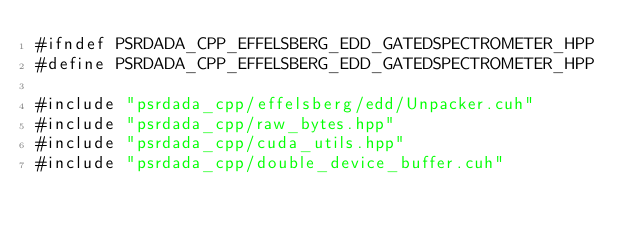Convert code to text. <code><loc_0><loc_0><loc_500><loc_500><_Cuda_>#ifndef PSRDADA_CPP_EFFELSBERG_EDD_GATEDSPECTROMETER_HPP
#define PSRDADA_CPP_EFFELSBERG_EDD_GATEDSPECTROMETER_HPP

#include "psrdada_cpp/effelsberg/edd/Unpacker.cuh"
#include "psrdada_cpp/raw_bytes.hpp"
#include "psrdada_cpp/cuda_utils.hpp"
#include "psrdada_cpp/double_device_buffer.cuh"</code> 